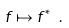Convert formula to latex. <formula><loc_0><loc_0><loc_500><loc_500>f \mapsto f ^ { * } \ .</formula> 